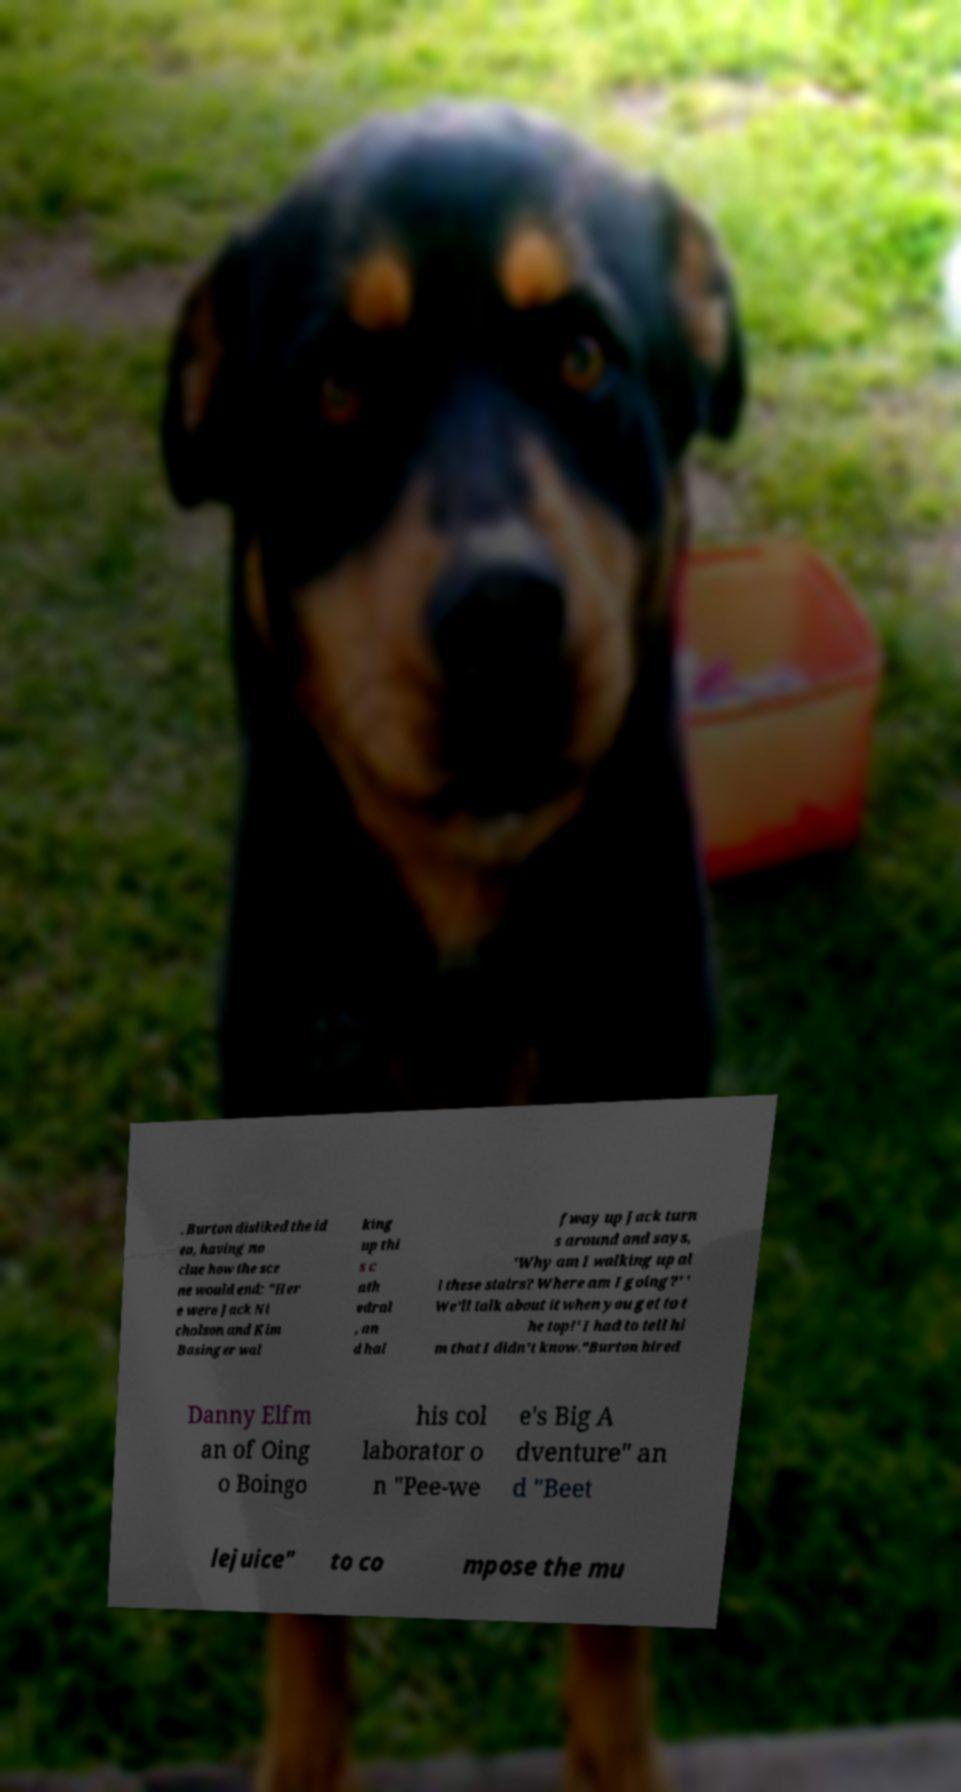I need the written content from this picture converted into text. Can you do that? . Burton disliked the id ea, having no clue how the sce ne would end: "Her e were Jack Ni cholson and Kim Basinger wal king up thi s c ath edral , an d hal fway up Jack turn s around and says, 'Why am I walking up al l these stairs? Where am I going?' ' We'll talk about it when you get to t he top!' I had to tell hi m that I didn't know."Burton hired Danny Elfm an of Oing o Boingo his col laborator o n "Pee-we e's Big A dventure" an d "Beet lejuice" to co mpose the mu 